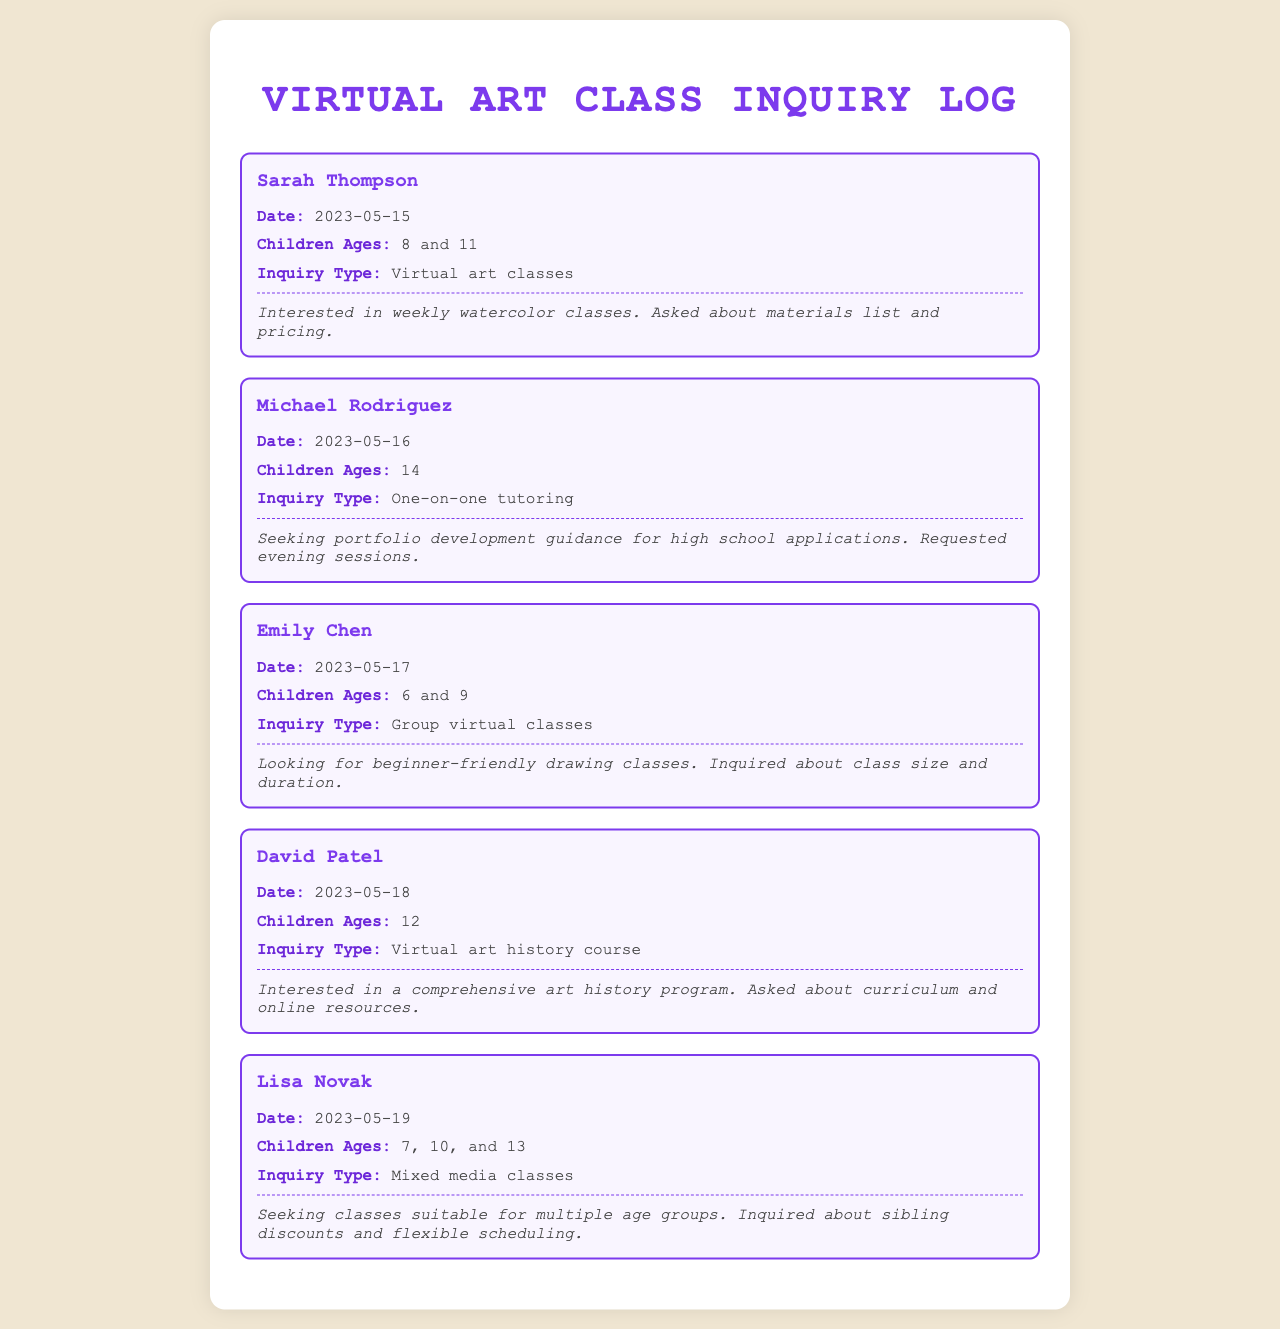What is the name of the first parent mentioned? The first parent mentioned in the document is Sarah Thompson.
Answer: Sarah Thompson What date did Michael Rodriguez make his inquiry? The inquiry from Michael Rodriguez was made on May 16, 2023.
Answer: 2023-05-16 How many children does Lisa Novak have? Lisa Novak has three children, as indicated by their ages listed.
Answer: 3 What type of classes is Emily Chen interested in? Emily Chen is inquiring about beginner-friendly drawing classes for her children.
Answer: Group virtual classes Which parent requested evening sessions? The parent who requested evening sessions for tutoring was Michael Rodriguez.
Answer: Michael Rodriguez What age range do Sarah Thompson's children fall into? Sarah Thompson's children are aged 8 and 11 years old.
Answer: 8 and 11 What inquiry type was made by David Patel? David Patel made an inquiry about a virtual art history course.
Answer: Virtual art history course How did Lisa Novak inquire about scheduling? Lisa Novak inquired about flexible scheduling for her mixed media classes.
Answer: Flexible scheduling Which parent was looking for sibling discounts? The parent who was looking for sibling discounts was Lisa Novak.
Answer: Lisa Novak 